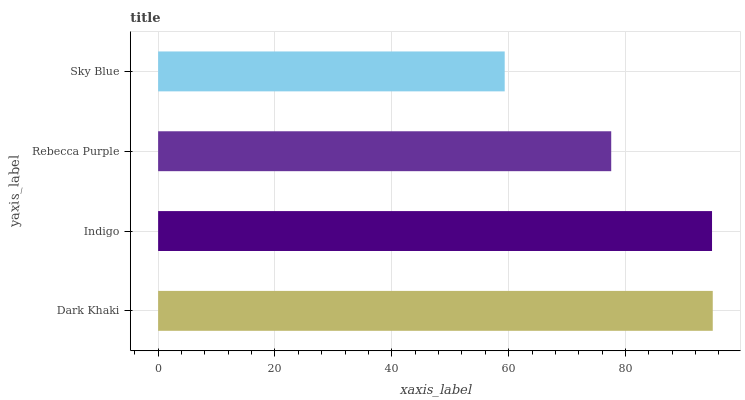Is Sky Blue the minimum?
Answer yes or no. Yes. Is Dark Khaki the maximum?
Answer yes or no. Yes. Is Indigo the minimum?
Answer yes or no. No. Is Indigo the maximum?
Answer yes or no. No. Is Dark Khaki greater than Indigo?
Answer yes or no. Yes. Is Indigo less than Dark Khaki?
Answer yes or no. Yes. Is Indigo greater than Dark Khaki?
Answer yes or no. No. Is Dark Khaki less than Indigo?
Answer yes or no. No. Is Indigo the high median?
Answer yes or no. Yes. Is Rebecca Purple the low median?
Answer yes or no. Yes. Is Rebecca Purple the high median?
Answer yes or no. No. Is Sky Blue the low median?
Answer yes or no. No. 